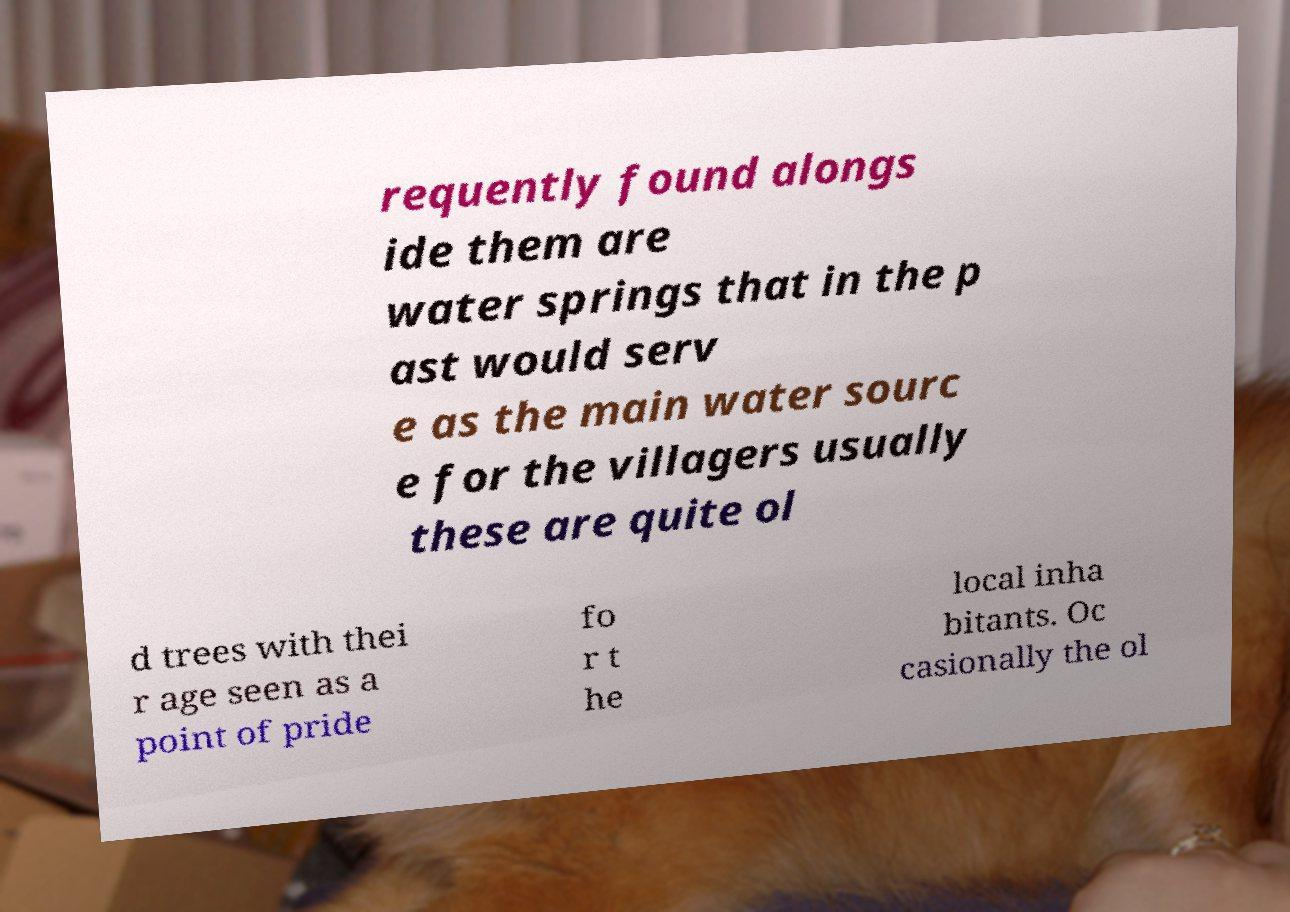There's text embedded in this image that I need extracted. Can you transcribe it verbatim? requently found alongs ide them are water springs that in the p ast would serv e as the main water sourc e for the villagers usually these are quite ol d trees with thei r age seen as a point of pride fo r t he local inha bitants. Oc casionally the ol 